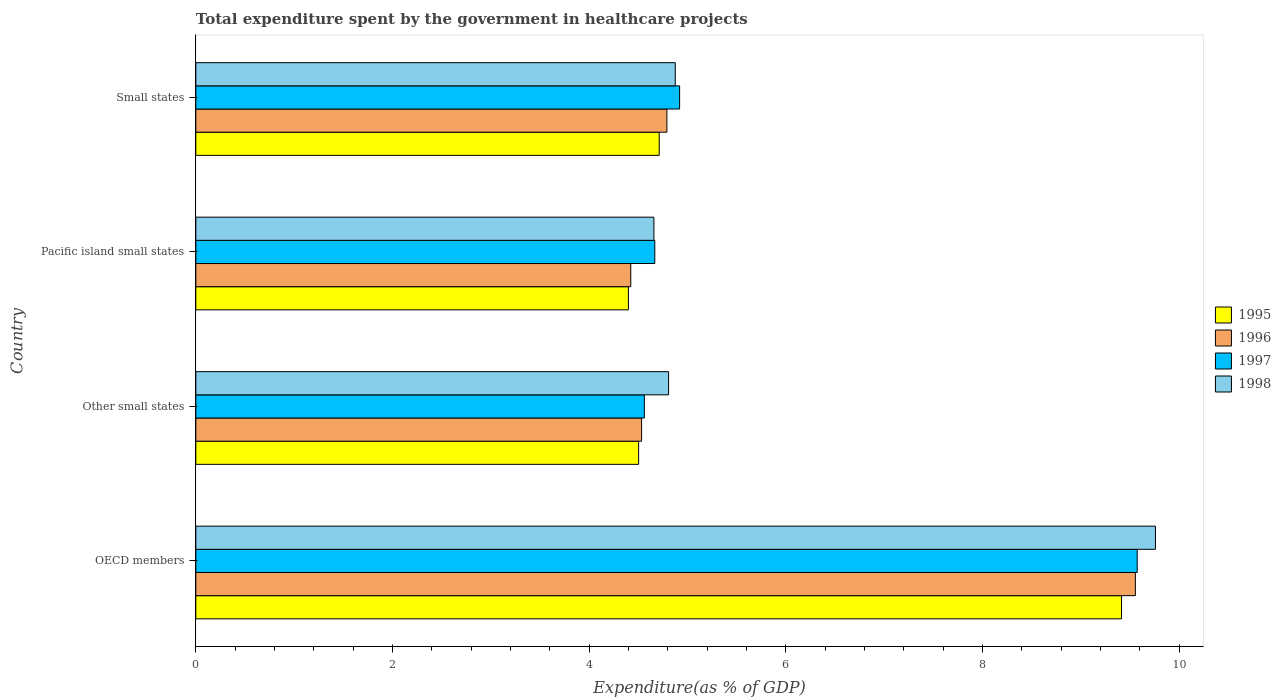How many groups of bars are there?
Your response must be concise. 4. Are the number of bars per tick equal to the number of legend labels?
Offer a very short reply. Yes. How many bars are there on the 2nd tick from the top?
Ensure brevity in your answer.  4. How many bars are there on the 1st tick from the bottom?
Provide a succinct answer. 4. What is the label of the 3rd group of bars from the top?
Make the answer very short. Other small states. In how many cases, is the number of bars for a given country not equal to the number of legend labels?
Provide a short and direct response. 0. What is the total expenditure spent by the government in healthcare projects in 1996 in Small states?
Your answer should be very brief. 4.79. Across all countries, what is the maximum total expenditure spent by the government in healthcare projects in 1995?
Keep it short and to the point. 9.41. Across all countries, what is the minimum total expenditure spent by the government in healthcare projects in 1995?
Your answer should be compact. 4.4. In which country was the total expenditure spent by the government in healthcare projects in 1998 maximum?
Your answer should be compact. OECD members. In which country was the total expenditure spent by the government in healthcare projects in 1998 minimum?
Your response must be concise. Pacific island small states. What is the total total expenditure spent by the government in healthcare projects in 1995 in the graph?
Provide a short and direct response. 23.03. What is the difference between the total expenditure spent by the government in healthcare projects in 1997 in OECD members and that in Small states?
Your answer should be compact. 4.65. What is the difference between the total expenditure spent by the government in healthcare projects in 1998 in Other small states and the total expenditure spent by the government in healthcare projects in 1995 in Small states?
Your response must be concise. 0.1. What is the average total expenditure spent by the government in healthcare projects in 1996 per country?
Keep it short and to the point. 5.82. What is the difference between the total expenditure spent by the government in healthcare projects in 1995 and total expenditure spent by the government in healthcare projects in 1998 in Small states?
Provide a short and direct response. -0.16. In how many countries, is the total expenditure spent by the government in healthcare projects in 1996 greater than 4 %?
Ensure brevity in your answer.  4. What is the ratio of the total expenditure spent by the government in healthcare projects in 1995 in OECD members to that in Small states?
Make the answer very short. 2. Is the total expenditure spent by the government in healthcare projects in 1998 in Pacific island small states less than that in Small states?
Provide a short and direct response. Yes. Is the difference between the total expenditure spent by the government in healthcare projects in 1995 in Other small states and Small states greater than the difference between the total expenditure spent by the government in healthcare projects in 1998 in Other small states and Small states?
Offer a terse response. No. What is the difference between the highest and the second highest total expenditure spent by the government in healthcare projects in 1997?
Keep it short and to the point. 4.65. What is the difference between the highest and the lowest total expenditure spent by the government in healthcare projects in 1997?
Ensure brevity in your answer.  5.01. In how many countries, is the total expenditure spent by the government in healthcare projects in 1996 greater than the average total expenditure spent by the government in healthcare projects in 1996 taken over all countries?
Give a very brief answer. 1. Is the sum of the total expenditure spent by the government in healthcare projects in 1997 in OECD members and Pacific island small states greater than the maximum total expenditure spent by the government in healthcare projects in 1996 across all countries?
Provide a short and direct response. Yes. Is it the case that in every country, the sum of the total expenditure spent by the government in healthcare projects in 1995 and total expenditure spent by the government in healthcare projects in 1998 is greater than the sum of total expenditure spent by the government in healthcare projects in 1996 and total expenditure spent by the government in healthcare projects in 1997?
Your answer should be compact. No. What does the 2nd bar from the top in OECD members represents?
Your answer should be very brief. 1997. How many bars are there?
Provide a short and direct response. 16. How many countries are there in the graph?
Your answer should be very brief. 4. What is the difference between two consecutive major ticks on the X-axis?
Offer a terse response. 2. Are the values on the major ticks of X-axis written in scientific E-notation?
Offer a terse response. No. How many legend labels are there?
Your answer should be very brief. 4. What is the title of the graph?
Your answer should be very brief. Total expenditure spent by the government in healthcare projects. What is the label or title of the X-axis?
Ensure brevity in your answer.  Expenditure(as % of GDP). What is the Expenditure(as % of GDP) in 1995 in OECD members?
Give a very brief answer. 9.41. What is the Expenditure(as % of GDP) of 1996 in OECD members?
Keep it short and to the point. 9.55. What is the Expenditure(as % of GDP) of 1997 in OECD members?
Your response must be concise. 9.57. What is the Expenditure(as % of GDP) of 1998 in OECD members?
Your answer should be compact. 9.76. What is the Expenditure(as % of GDP) of 1995 in Other small states?
Provide a succinct answer. 4.5. What is the Expenditure(as % of GDP) in 1996 in Other small states?
Ensure brevity in your answer.  4.53. What is the Expenditure(as % of GDP) in 1997 in Other small states?
Provide a short and direct response. 4.56. What is the Expenditure(as % of GDP) in 1998 in Other small states?
Make the answer very short. 4.81. What is the Expenditure(as % of GDP) in 1995 in Pacific island small states?
Provide a succinct answer. 4.4. What is the Expenditure(as % of GDP) of 1996 in Pacific island small states?
Give a very brief answer. 4.42. What is the Expenditure(as % of GDP) of 1997 in Pacific island small states?
Give a very brief answer. 4.67. What is the Expenditure(as % of GDP) in 1998 in Pacific island small states?
Keep it short and to the point. 4.66. What is the Expenditure(as % of GDP) in 1995 in Small states?
Your response must be concise. 4.71. What is the Expenditure(as % of GDP) of 1996 in Small states?
Ensure brevity in your answer.  4.79. What is the Expenditure(as % of GDP) in 1997 in Small states?
Your answer should be very brief. 4.92. What is the Expenditure(as % of GDP) of 1998 in Small states?
Give a very brief answer. 4.88. Across all countries, what is the maximum Expenditure(as % of GDP) in 1995?
Provide a succinct answer. 9.41. Across all countries, what is the maximum Expenditure(as % of GDP) of 1996?
Offer a terse response. 9.55. Across all countries, what is the maximum Expenditure(as % of GDP) in 1997?
Offer a terse response. 9.57. Across all countries, what is the maximum Expenditure(as % of GDP) of 1998?
Keep it short and to the point. 9.76. Across all countries, what is the minimum Expenditure(as % of GDP) in 1995?
Your answer should be compact. 4.4. Across all countries, what is the minimum Expenditure(as % of GDP) of 1996?
Keep it short and to the point. 4.42. Across all countries, what is the minimum Expenditure(as % of GDP) in 1997?
Keep it short and to the point. 4.56. Across all countries, what is the minimum Expenditure(as % of GDP) of 1998?
Your answer should be compact. 4.66. What is the total Expenditure(as % of GDP) of 1995 in the graph?
Ensure brevity in your answer.  23.03. What is the total Expenditure(as % of GDP) in 1996 in the graph?
Make the answer very short. 23.3. What is the total Expenditure(as % of GDP) of 1997 in the graph?
Offer a terse response. 23.72. What is the total Expenditure(as % of GDP) of 1998 in the graph?
Ensure brevity in your answer.  24.1. What is the difference between the Expenditure(as % of GDP) of 1995 in OECD members and that in Other small states?
Keep it short and to the point. 4.91. What is the difference between the Expenditure(as % of GDP) of 1996 in OECD members and that in Other small states?
Keep it short and to the point. 5.02. What is the difference between the Expenditure(as % of GDP) of 1997 in OECD members and that in Other small states?
Provide a short and direct response. 5.01. What is the difference between the Expenditure(as % of GDP) of 1998 in OECD members and that in Other small states?
Make the answer very short. 4.95. What is the difference between the Expenditure(as % of GDP) in 1995 in OECD members and that in Pacific island small states?
Offer a very short reply. 5.01. What is the difference between the Expenditure(as % of GDP) in 1996 in OECD members and that in Pacific island small states?
Provide a short and direct response. 5.13. What is the difference between the Expenditure(as % of GDP) in 1997 in OECD members and that in Pacific island small states?
Make the answer very short. 4.91. What is the difference between the Expenditure(as % of GDP) of 1998 in OECD members and that in Pacific island small states?
Provide a succinct answer. 5.1. What is the difference between the Expenditure(as % of GDP) of 1995 in OECD members and that in Small states?
Offer a very short reply. 4.7. What is the difference between the Expenditure(as % of GDP) in 1996 in OECD members and that in Small states?
Make the answer very short. 4.76. What is the difference between the Expenditure(as % of GDP) of 1997 in OECD members and that in Small states?
Your answer should be very brief. 4.65. What is the difference between the Expenditure(as % of GDP) in 1998 in OECD members and that in Small states?
Offer a very short reply. 4.88. What is the difference between the Expenditure(as % of GDP) of 1995 in Other small states and that in Pacific island small states?
Your answer should be compact. 0.1. What is the difference between the Expenditure(as % of GDP) in 1996 in Other small states and that in Pacific island small states?
Your answer should be very brief. 0.11. What is the difference between the Expenditure(as % of GDP) in 1997 in Other small states and that in Pacific island small states?
Your answer should be compact. -0.11. What is the difference between the Expenditure(as % of GDP) in 1998 in Other small states and that in Pacific island small states?
Provide a short and direct response. 0.15. What is the difference between the Expenditure(as % of GDP) in 1995 in Other small states and that in Small states?
Provide a succinct answer. -0.21. What is the difference between the Expenditure(as % of GDP) in 1996 in Other small states and that in Small states?
Provide a succinct answer. -0.26. What is the difference between the Expenditure(as % of GDP) in 1997 in Other small states and that in Small states?
Give a very brief answer. -0.36. What is the difference between the Expenditure(as % of GDP) in 1998 in Other small states and that in Small states?
Provide a short and direct response. -0.07. What is the difference between the Expenditure(as % of GDP) of 1995 in Pacific island small states and that in Small states?
Keep it short and to the point. -0.31. What is the difference between the Expenditure(as % of GDP) of 1996 in Pacific island small states and that in Small states?
Offer a terse response. -0.37. What is the difference between the Expenditure(as % of GDP) in 1997 in Pacific island small states and that in Small states?
Your answer should be very brief. -0.25. What is the difference between the Expenditure(as % of GDP) in 1998 in Pacific island small states and that in Small states?
Offer a terse response. -0.22. What is the difference between the Expenditure(as % of GDP) of 1995 in OECD members and the Expenditure(as % of GDP) of 1996 in Other small states?
Your answer should be compact. 4.88. What is the difference between the Expenditure(as % of GDP) of 1995 in OECD members and the Expenditure(as % of GDP) of 1997 in Other small states?
Your answer should be very brief. 4.85. What is the difference between the Expenditure(as % of GDP) in 1995 in OECD members and the Expenditure(as % of GDP) in 1998 in Other small states?
Offer a terse response. 4.61. What is the difference between the Expenditure(as % of GDP) in 1996 in OECD members and the Expenditure(as % of GDP) in 1997 in Other small states?
Offer a terse response. 4.99. What is the difference between the Expenditure(as % of GDP) of 1996 in OECD members and the Expenditure(as % of GDP) of 1998 in Other small states?
Ensure brevity in your answer.  4.75. What is the difference between the Expenditure(as % of GDP) of 1997 in OECD members and the Expenditure(as % of GDP) of 1998 in Other small states?
Offer a very short reply. 4.77. What is the difference between the Expenditure(as % of GDP) of 1995 in OECD members and the Expenditure(as % of GDP) of 1996 in Pacific island small states?
Offer a terse response. 4.99. What is the difference between the Expenditure(as % of GDP) of 1995 in OECD members and the Expenditure(as % of GDP) of 1997 in Pacific island small states?
Your response must be concise. 4.75. What is the difference between the Expenditure(as % of GDP) in 1995 in OECD members and the Expenditure(as % of GDP) in 1998 in Pacific island small states?
Make the answer very short. 4.76. What is the difference between the Expenditure(as % of GDP) in 1996 in OECD members and the Expenditure(as % of GDP) in 1997 in Pacific island small states?
Your answer should be very brief. 4.89. What is the difference between the Expenditure(as % of GDP) in 1996 in OECD members and the Expenditure(as % of GDP) in 1998 in Pacific island small states?
Ensure brevity in your answer.  4.9. What is the difference between the Expenditure(as % of GDP) of 1997 in OECD members and the Expenditure(as % of GDP) of 1998 in Pacific island small states?
Give a very brief answer. 4.91. What is the difference between the Expenditure(as % of GDP) of 1995 in OECD members and the Expenditure(as % of GDP) of 1996 in Small states?
Offer a very short reply. 4.62. What is the difference between the Expenditure(as % of GDP) in 1995 in OECD members and the Expenditure(as % of GDP) in 1997 in Small states?
Provide a succinct answer. 4.49. What is the difference between the Expenditure(as % of GDP) of 1995 in OECD members and the Expenditure(as % of GDP) of 1998 in Small states?
Make the answer very short. 4.54. What is the difference between the Expenditure(as % of GDP) of 1996 in OECD members and the Expenditure(as % of GDP) of 1997 in Small states?
Offer a very short reply. 4.63. What is the difference between the Expenditure(as % of GDP) in 1996 in OECD members and the Expenditure(as % of GDP) in 1998 in Small states?
Ensure brevity in your answer.  4.68. What is the difference between the Expenditure(as % of GDP) of 1997 in OECD members and the Expenditure(as % of GDP) of 1998 in Small states?
Keep it short and to the point. 4.7. What is the difference between the Expenditure(as % of GDP) of 1995 in Other small states and the Expenditure(as % of GDP) of 1996 in Pacific island small states?
Make the answer very short. 0.08. What is the difference between the Expenditure(as % of GDP) of 1995 in Other small states and the Expenditure(as % of GDP) of 1997 in Pacific island small states?
Your response must be concise. -0.16. What is the difference between the Expenditure(as % of GDP) in 1995 in Other small states and the Expenditure(as % of GDP) in 1998 in Pacific island small states?
Your answer should be very brief. -0.16. What is the difference between the Expenditure(as % of GDP) of 1996 in Other small states and the Expenditure(as % of GDP) of 1997 in Pacific island small states?
Give a very brief answer. -0.13. What is the difference between the Expenditure(as % of GDP) of 1996 in Other small states and the Expenditure(as % of GDP) of 1998 in Pacific island small states?
Your answer should be compact. -0.12. What is the difference between the Expenditure(as % of GDP) of 1997 in Other small states and the Expenditure(as % of GDP) of 1998 in Pacific island small states?
Provide a short and direct response. -0.1. What is the difference between the Expenditure(as % of GDP) in 1995 in Other small states and the Expenditure(as % of GDP) in 1996 in Small states?
Your answer should be compact. -0.29. What is the difference between the Expenditure(as % of GDP) of 1995 in Other small states and the Expenditure(as % of GDP) of 1997 in Small states?
Your answer should be very brief. -0.42. What is the difference between the Expenditure(as % of GDP) in 1995 in Other small states and the Expenditure(as % of GDP) in 1998 in Small states?
Give a very brief answer. -0.37. What is the difference between the Expenditure(as % of GDP) in 1996 in Other small states and the Expenditure(as % of GDP) in 1997 in Small states?
Your answer should be compact. -0.39. What is the difference between the Expenditure(as % of GDP) in 1996 in Other small states and the Expenditure(as % of GDP) in 1998 in Small states?
Give a very brief answer. -0.34. What is the difference between the Expenditure(as % of GDP) of 1997 in Other small states and the Expenditure(as % of GDP) of 1998 in Small states?
Provide a succinct answer. -0.31. What is the difference between the Expenditure(as % of GDP) in 1995 in Pacific island small states and the Expenditure(as % of GDP) in 1996 in Small states?
Offer a terse response. -0.39. What is the difference between the Expenditure(as % of GDP) in 1995 in Pacific island small states and the Expenditure(as % of GDP) in 1997 in Small states?
Provide a succinct answer. -0.52. What is the difference between the Expenditure(as % of GDP) of 1995 in Pacific island small states and the Expenditure(as % of GDP) of 1998 in Small states?
Your response must be concise. -0.48. What is the difference between the Expenditure(as % of GDP) of 1996 in Pacific island small states and the Expenditure(as % of GDP) of 1997 in Small states?
Offer a very short reply. -0.5. What is the difference between the Expenditure(as % of GDP) of 1996 in Pacific island small states and the Expenditure(as % of GDP) of 1998 in Small states?
Your answer should be very brief. -0.45. What is the difference between the Expenditure(as % of GDP) in 1997 in Pacific island small states and the Expenditure(as % of GDP) in 1998 in Small states?
Provide a short and direct response. -0.21. What is the average Expenditure(as % of GDP) of 1995 per country?
Provide a short and direct response. 5.76. What is the average Expenditure(as % of GDP) of 1996 per country?
Your response must be concise. 5.83. What is the average Expenditure(as % of GDP) in 1997 per country?
Offer a very short reply. 5.93. What is the average Expenditure(as % of GDP) in 1998 per country?
Your answer should be compact. 6.02. What is the difference between the Expenditure(as % of GDP) of 1995 and Expenditure(as % of GDP) of 1996 in OECD members?
Ensure brevity in your answer.  -0.14. What is the difference between the Expenditure(as % of GDP) of 1995 and Expenditure(as % of GDP) of 1997 in OECD members?
Your response must be concise. -0.16. What is the difference between the Expenditure(as % of GDP) in 1995 and Expenditure(as % of GDP) in 1998 in OECD members?
Ensure brevity in your answer.  -0.34. What is the difference between the Expenditure(as % of GDP) in 1996 and Expenditure(as % of GDP) in 1997 in OECD members?
Your answer should be compact. -0.02. What is the difference between the Expenditure(as % of GDP) in 1996 and Expenditure(as % of GDP) in 1998 in OECD members?
Provide a succinct answer. -0.2. What is the difference between the Expenditure(as % of GDP) of 1997 and Expenditure(as % of GDP) of 1998 in OECD members?
Make the answer very short. -0.19. What is the difference between the Expenditure(as % of GDP) in 1995 and Expenditure(as % of GDP) in 1996 in Other small states?
Your answer should be compact. -0.03. What is the difference between the Expenditure(as % of GDP) of 1995 and Expenditure(as % of GDP) of 1997 in Other small states?
Your answer should be very brief. -0.06. What is the difference between the Expenditure(as % of GDP) in 1995 and Expenditure(as % of GDP) in 1998 in Other small states?
Your answer should be compact. -0.3. What is the difference between the Expenditure(as % of GDP) in 1996 and Expenditure(as % of GDP) in 1997 in Other small states?
Ensure brevity in your answer.  -0.03. What is the difference between the Expenditure(as % of GDP) in 1996 and Expenditure(as % of GDP) in 1998 in Other small states?
Keep it short and to the point. -0.27. What is the difference between the Expenditure(as % of GDP) of 1997 and Expenditure(as % of GDP) of 1998 in Other small states?
Your answer should be very brief. -0.25. What is the difference between the Expenditure(as % of GDP) in 1995 and Expenditure(as % of GDP) in 1996 in Pacific island small states?
Offer a terse response. -0.02. What is the difference between the Expenditure(as % of GDP) in 1995 and Expenditure(as % of GDP) in 1997 in Pacific island small states?
Your answer should be very brief. -0.27. What is the difference between the Expenditure(as % of GDP) of 1995 and Expenditure(as % of GDP) of 1998 in Pacific island small states?
Your answer should be very brief. -0.26. What is the difference between the Expenditure(as % of GDP) in 1996 and Expenditure(as % of GDP) in 1997 in Pacific island small states?
Your response must be concise. -0.24. What is the difference between the Expenditure(as % of GDP) in 1996 and Expenditure(as % of GDP) in 1998 in Pacific island small states?
Ensure brevity in your answer.  -0.24. What is the difference between the Expenditure(as % of GDP) of 1997 and Expenditure(as % of GDP) of 1998 in Pacific island small states?
Give a very brief answer. 0.01. What is the difference between the Expenditure(as % of GDP) in 1995 and Expenditure(as % of GDP) in 1996 in Small states?
Offer a very short reply. -0.08. What is the difference between the Expenditure(as % of GDP) of 1995 and Expenditure(as % of GDP) of 1997 in Small states?
Your answer should be compact. -0.21. What is the difference between the Expenditure(as % of GDP) of 1995 and Expenditure(as % of GDP) of 1998 in Small states?
Your answer should be very brief. -0.16. What is the difference between the Expenditure(as % of GDP) in 1996 and Expenditure(as % of GDP) in 1997 in Small states?
Offer a very short reply. -0.13. What is the difference between the Expenditure(as % of GDP) of 1996 and Expenditure(as % of GDP) of 1998 in Small states?
Keep it short and to the point. -0.09. What is the difference between the Expenditure(as % of GDP) of 1997 and Expenditure(as % of GDP) of 1998 in Small states?
Offer a very short reply. 0.04. What is the ratio of the Expenditure(as % of GDP) in 1995 in OECD members to that in Other small states?
Ensure brevity in your answer.  2.09. What is the ratio of the Expenditure(as % of GDP) in 1996 in OECD members to that in Other small states?
Give a very brief answer. 2.11. What is the ratio of the Expenditure(as % of GDP) of 1997 in OECD members to that in Other small states?
Your response must be concise. 2.1. What is the ratio of the Expenditure(as % of GDP) of 1998 in OECD members to that in Other small states?
Provide a short and direct response. 2.03. What is the ratio of the Expenditure(as % of GDP) in 1995 in OECD members to that in Pacific island small states?
Make the answer very short. 2.14. What is the ratio of the Expenditure(as % of GDP) in 1996 in OECD members to that in Pacific island small states?
Make the answer very short. 2.16. What is the ratio of the Expenditure(as % of GDP) in 1997 in OECD members to that in Pacific island small states?
Your answer should be very brief. 2.05. What is the ratio of the Expenditure(as % of GDP) of 1998 in OECD members to that in Pacific island small states?
Make the answer very short. 2.1. What is the ratio of the Expenditure(as % of GDP) of 1995 in OECD members to that in Small states?
Offer a very short reply. 2. What is the ratio of the Expenditure(as % of GDP) in 1996 in OECD members to that in Small states?
Your response must be concise. 1.99. What is the ratio of the Expenditure(as % of GDP) in 1997 in OECD members to that in Small states?
Your answer should be compact. 1.95. What is the ratio of the Expenditure(as % of GDP) in 1998 in OECD members to that in Small states?
Provide a succinct answer. 2. What is the ratio of the Expenditure(as % of GDP) of 1995 in Other small states to that in Pacific island small states?
Offer a very short reply. 1.02. What is the ratio of the Expenditure(as % of GDP) in 1996 in Other small states to that in Pacific island small states?
Your answer should be compact. 1.02. What is the ratio of the Expenditure(as % of GDP) of 1997 in Other small states to that in Pacific island small states?
Offer a very short reply. 0.98. What is the ratio of the Expenditure(as % of GDP) of 1998 in Other small states to that in Pacific island small states?
Give a very brief answer. 1.03. What is the ratio of the Expenditure(as % of GDP) in 1995 in Other small states to that in Small states?
Keep it short and to the point. 0.96. What is the ratio of the Expenditure(as % of GDP) in 1996 in Other small states to that in Small states?
Provide a short and direct response. 0.95. What is the ratio of the Expenditure(as % of GDP) in 1997 in Other small states to that in Small states?
Your answer should be very brief. 0.93. What is the ratio of the Expenditure(as % of GDP) in 1998 in Other small states to that in Small states?
Your response must be concise. 0.99. What is the ratio of the Expenditure(as % of GDP) in 1995 in Pacific island small states to that in Small states?
Your answer should be compact. 0.93. What is the ratio of the Expenditure(as % of GDP) of 1996 in Pacific island small states to that in Small states?
Ensure brevity in your answer.  0.92. What is the ratio of the Expenditure(as % of GDP) in 1997 in Pacific island small states to that in Small states?
Give a very brief answer. 0.95. What is the ratio of the Expenditure(as % of GDP) in 1998 in Pacific island small states to that in Small states?
Keep it short and to the point. 0.96. What is the difference between the highest and the second highest Expenditure(as % of GDP) in 1995?
Your answer should be compact. 4.7. What is the difference between the highest and the second highest Expenditure(as % of GDP) of 1996?
Offer a terse response. 4.76. What is the difference between the highest and the second highest Expenditure(as % of GDP) in 1997?
Your answer should be compact. 4.65. What is the difference between the highest and the second highest Expenditure(as % of GDP) in 1998?
Offer a very short reply. 4.88. What is the difference between the highest and the lowest Expenditure(as % of GDP) in 1995?
Offer a terse response. 5.01. What is the difference between the highest and the lowest Expenditure(as % of GDP) in 1996?
Your answer should be very brief. 5.13. What is the difference between the highest and the lowest Expenditure(as % of GDP) in 1997?
Provide a short and direct response. 5.01. What is the difference between the highest and the lowest Expenditure(as % of GDP) of 1998?
Your answer should be compact. 5.1. 